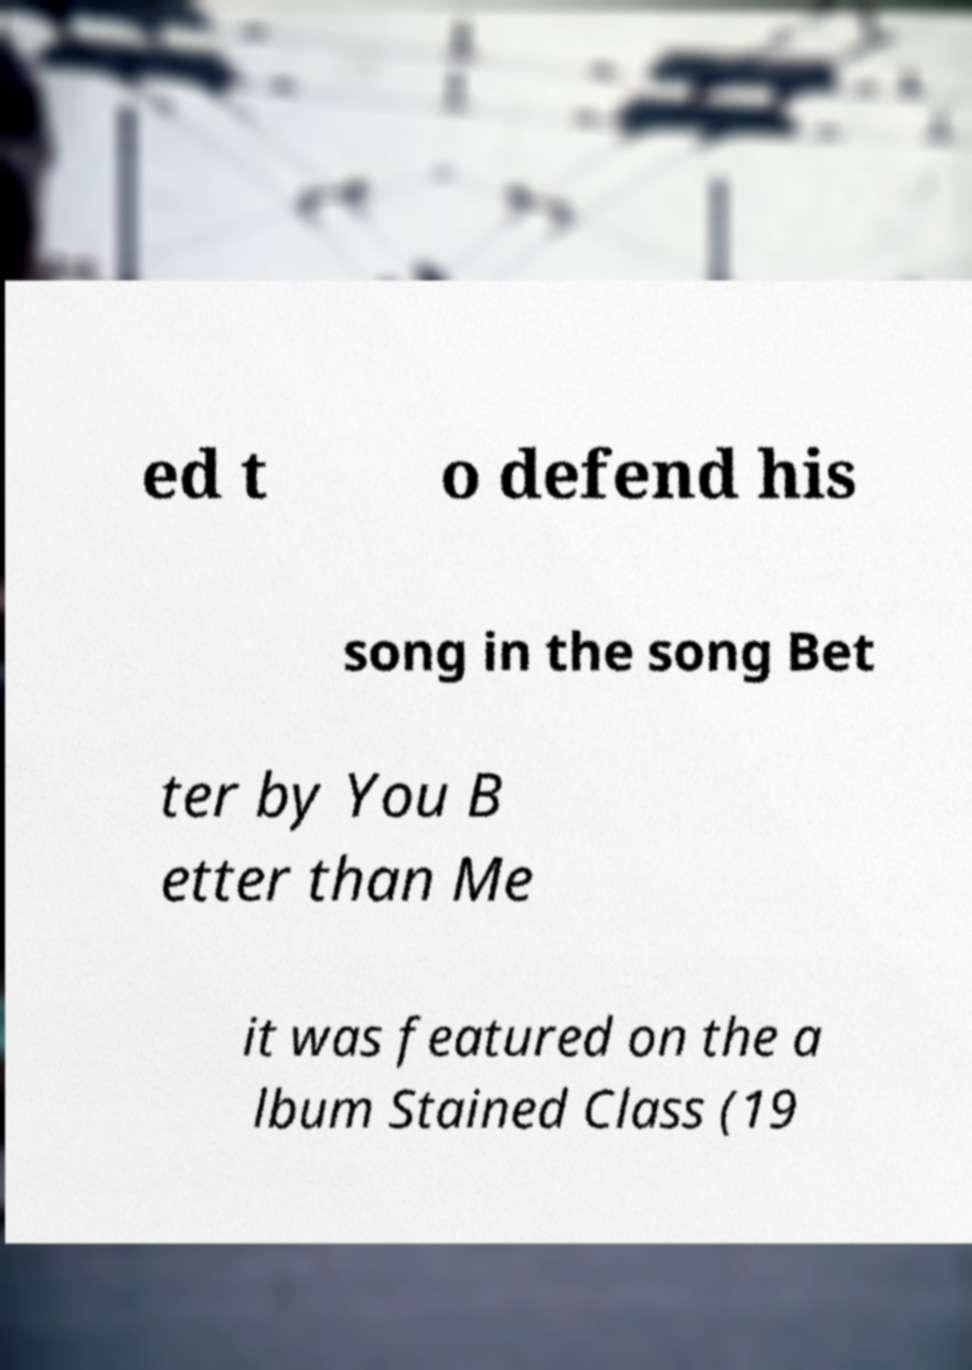Could you extract and type out the text from this image? ed t o defend his song in the song Bet ter by You B etter than Me it was featured on the a lbum Stained Class (19 